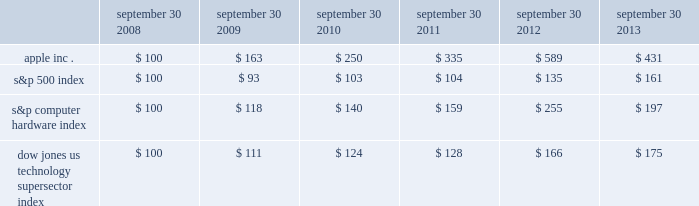Table of contents company stock performance the following graph shows a five-year comparison of cumulative total shareholder return , calculated on a dividend reinvested basis , for the company , the s&p 500 index , the s&p computer hardware index , and the dow jones u.s .
Technology supersector index .
The graph assumes $ 100 was invested in each of the company 2019s common stock , the s&p 500 index , the s&p computer hardware index , and the dow jones u.s .
Technology supersector index as of the market close on september 30 , 2008 .
Data points on the graph are annual .
Note that historic stock price performance is not necessarily indicative of future stock price performance .
Fiscal year ending september 30 .
Copyright 2013 s&p , a division of the mcgraw-hill companies inc .
All rights reserved .
Copyright 2013 dow jones & co .
All rights reserved .
*$ 100 invested on 9/30/08 in stock or index , including reinvestment of dividends .
September 30 , september 30 , september 30 , september 30 , september 30 , september 30 .

What is the 6 year total shareholder return on apple . inc.? 
Computations: ((431 - 100) / 100)
Answer: 3.31. Table of contents company stock performance the following graph shows a five-year comparison of cumulative total shareholder return , calculated on a dividend reinvested basis , for the company , the s&p 500 index , the s&p computer hardware index , and the dow jones u.s .
Technology supersector index .
The graph assumes $ 100 was invested in each of the company 2019s common stock , the s&p 500 index , the s&p computer hardware index , and the dow jones u.s .
Technology supersector index as of the market close on september 30 , 2008 .
Data points on the graph are annual .
Note that historic stock price performance is not necessarily indicative of future stock price performance .
Fiscal year ending september 30 .
Copyright 2013 s&p , a division of the mcgraw-hill companies inc .
All rights reserved .
Copyright 2013 dow jones & co .
All rights reserved .
*$ 100 invested on 9/30/08 in stock or index , including reinvestment of dividends .
September 30 , september 30 , september 30 , september 30 , september 30 , september 30 .

What was the cumulative change in value for the s&p index between 2008 and 2013? 
Computations: (161 - 100)
Answer: 61.0. 